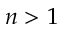<formula> <loc_0><loc_0><loc_500><loc_500>n > 1</formula> 